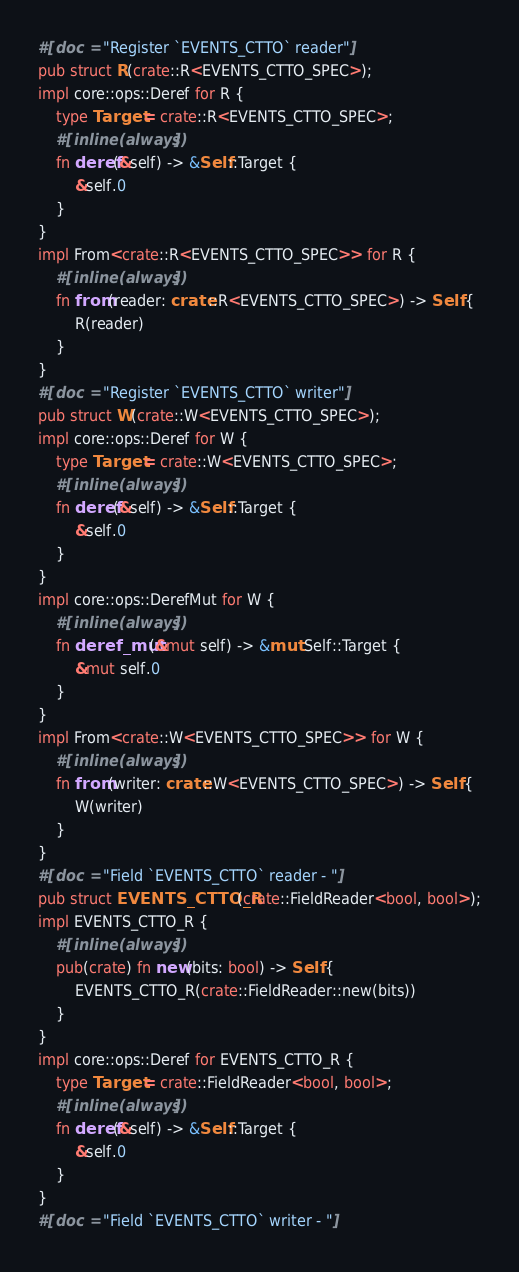<code> <loc_0><loc_0><loc_500><loc_500><_Rust_>#[doc = "Register `EVENTS_CTTO` reader"]
pub struct R(crate::R<EVENTS_CTTO_SPEC>);
impl core::ops::Deref for R {
    type Target = crate::R<EVENTS_CTTO_SPEC>;
    #[inline(always)]
    fn deref(&self) -> &Self::Target {
        &self.0
    }
}
impl From<crate::R<EVENTS_CTTO_SPEC>> for R {
    #[inline(always)]
    fn from(reader: crate::R<EVENTS_CTTO_SPEC>) -> Self {
        R(reader)
    }
}
#[doc = "Register `EVENTS_CTTO` writer"]
pub struct W(crate::W<EVENTS_CTTO_SPEC>);
impl core::ops::Deref for W {
    type Target = crate::W<EVENTS_CTTO_SPEC>;
    #[inline(always)]
    fn deref(&self) -> &Self::Target {
        &self.0
    }
}
impl core::ops::DerefMut for W {
    #[inline(always)]
    fn deref_mut(&mut self) -> &mut Self::Target {
        &mut self.0
    }
}
impl From<crate::W<EVENTS_CTTO_SPEC>> for W {
    #[inline(always)]
    fn from(writer: crate::W<EVENTS_CTTO_SPEC>) -> Self {
        W(writer)
    }
}
#[doc = "Field `EVENTS_CTTO` reader - "]
pub struct EVENTS_CTTO_R(crate::FieldReader<bool, bool>);
impl EVENTS_CTTO_R {
    #[inline(always)]
    pub(crate) fn new(bits: bool) -> Self {
        EVENTS_CTTO_R(crate::FieldReader::new(bits))
    }
}
impl core::ops::Deref for EVENTS_CTTO_R {
    type Target = crate::FieldReader<bool, bool>;
    #[inline(always)]
    fn deref(&self) -> &Self::Target {
        &self.0
    }
}
#[doc = "Field `EVENTS_CTTO` writer - "]</code> 